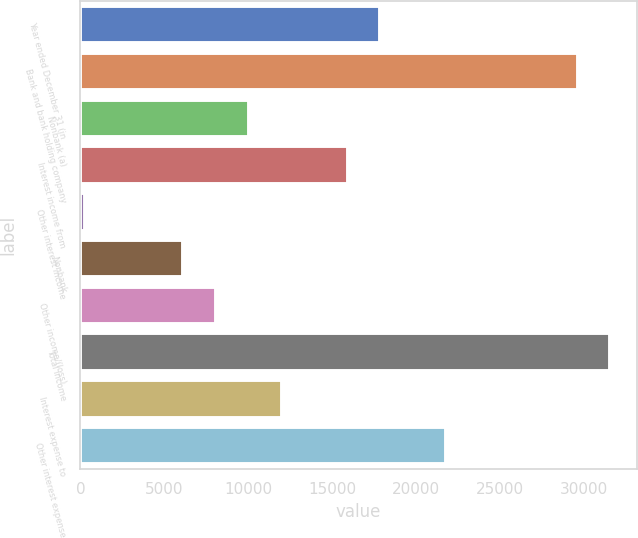<chart> <loc_0><loc_0><loc_500><loc_500><bar_chart><fcel>Year ended December 31 (in<fcel>Bank and bank holding company<fcel>Nonbank (a)<fcel>Interest income from<fcel>Other interest income<fcel>Nonbank<fcel>Other income/(loss)<fcel>Total income<fcel>Interest expense to<fcel>Other interest expense<nl><fcel>17897.9<fcel>29652.5<fcel>10061.5<fcel>15938.8<fcel>266<fcel>6143.3<fcel>8102.4<fcel>31611.6<fcel>12020.6<fcel>21816.1<nl></chart> 